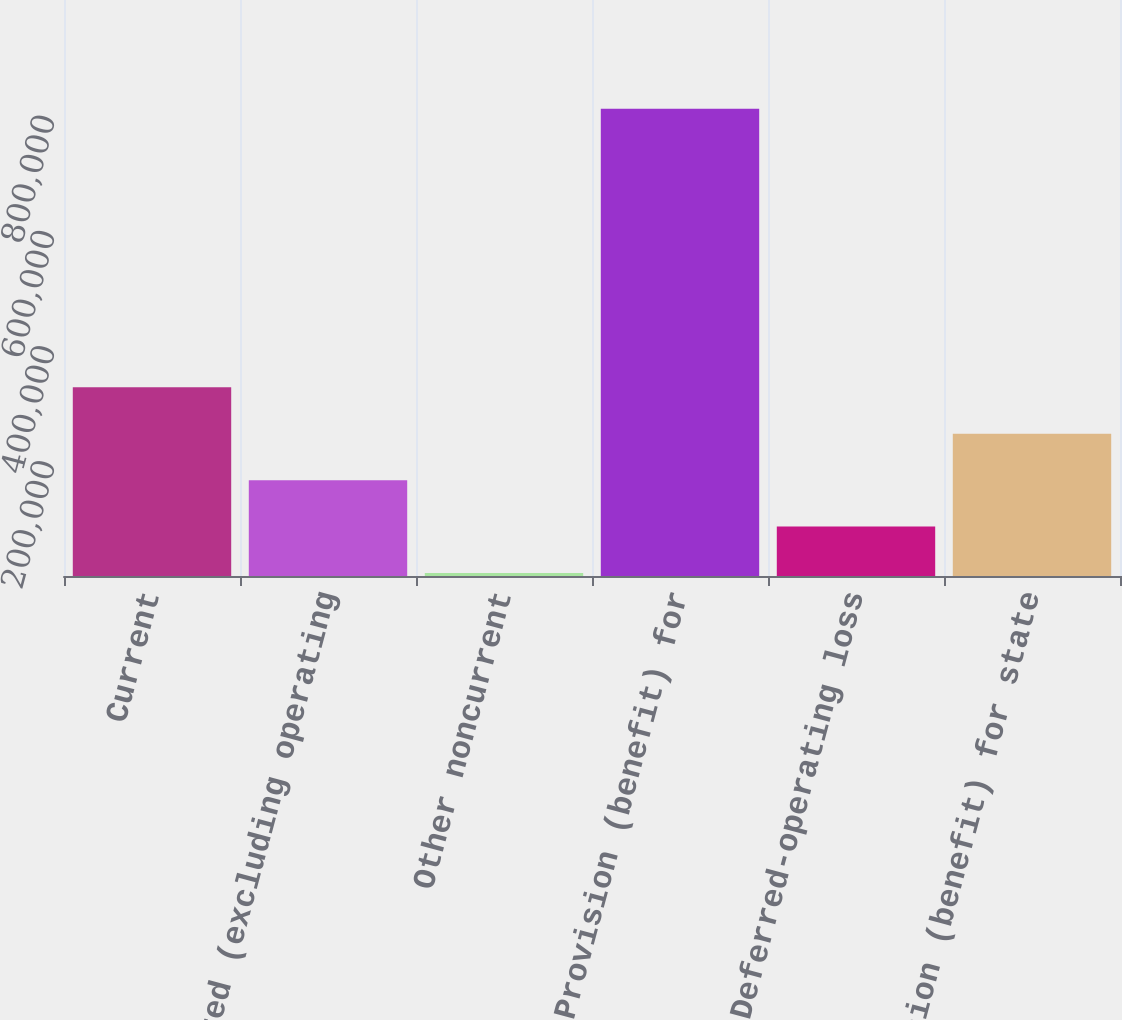<chart> <loc_0><loc_0><loc_500><loc_500><bar_chart><fcel>Current<fcel>Deferred (excluding operating<fcel>Other noncurrent<fcel>Provision (benefit) for<fcel>Deferred-operating loss<fcel>Provision (benefit) for state<nl><fcel>327655<fcel>166411<fcel>5167<fcel>811388<fcel>85789.1<fcel>247033<nl></chart> 